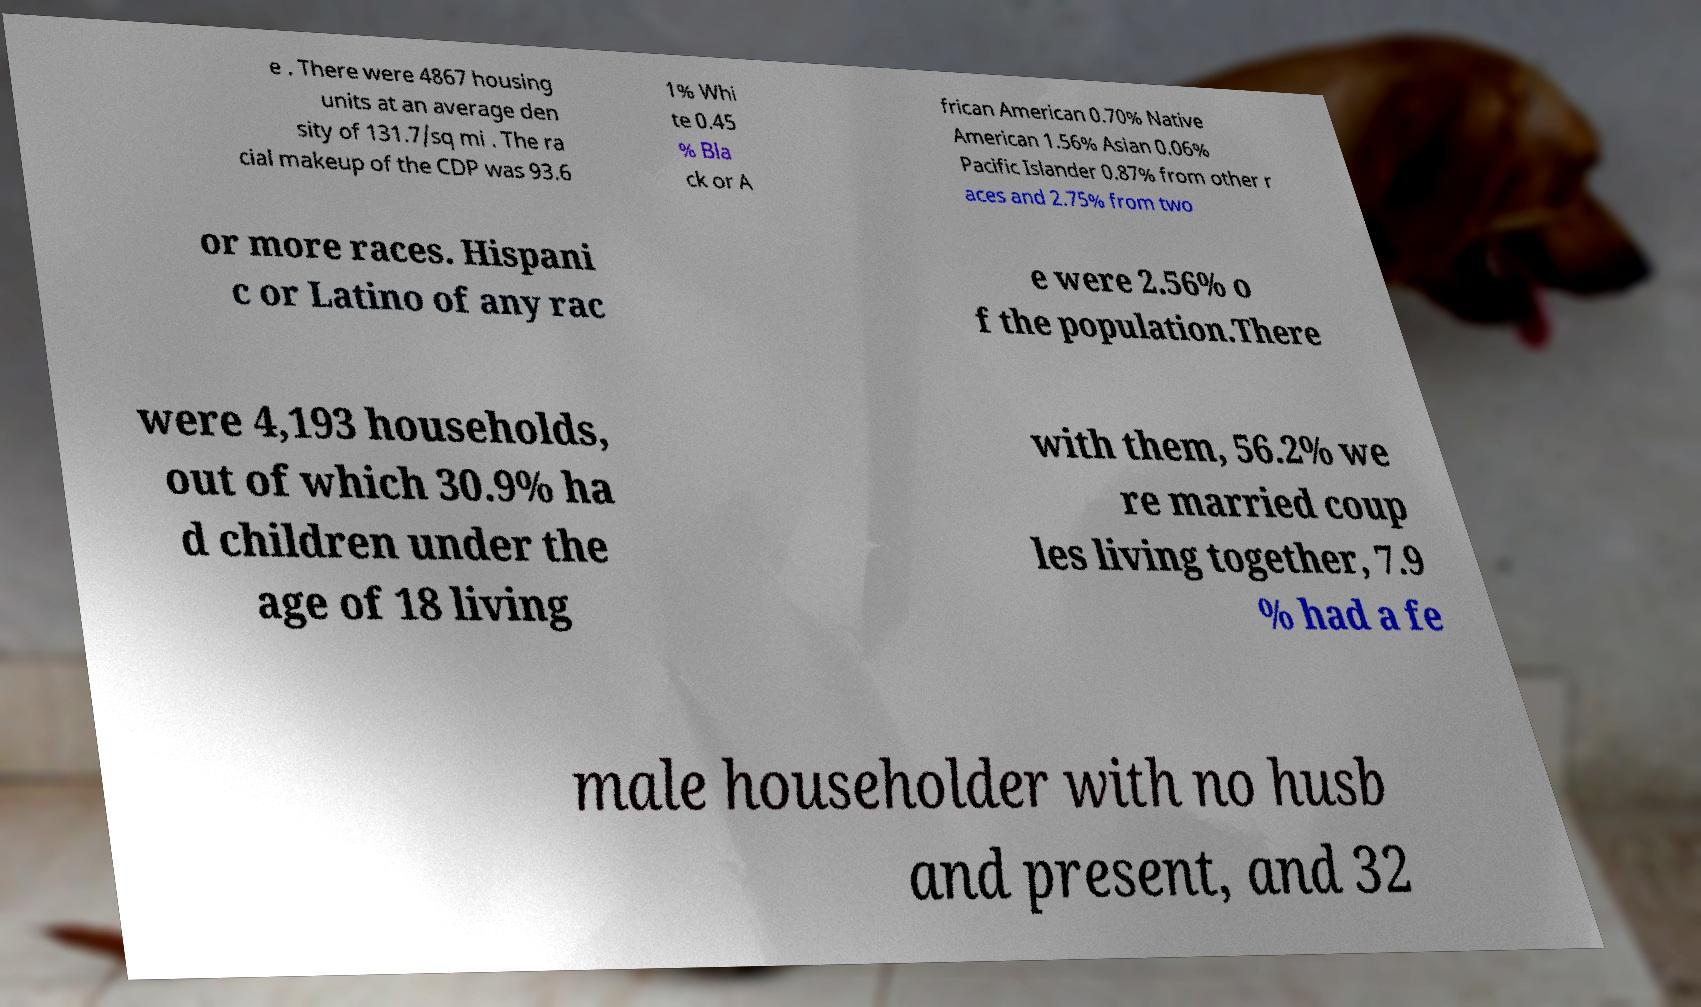Could you assist in decoding the text presented in this image and type it out clearly? e . There were 4867 housing units at an average den sity of 131.7/sq mi . The ra cial makeup of the CDP was 93.6 1% Whi te 0.45 % Bla ck or A frican American 0.70% Native American 1.56% Asian 0.06% Pacific Islander 0.87% from other r aces and 2.75% from two or more races. Hispani c or Latino of any rac e were 2.56% o f the population.There were 4,193 households, out of which 30.9% ha d children under the age of 18 living with them, 56.2% we re married coup les living together, 7.9 % had a fe male householder with no husb and present, and 32 